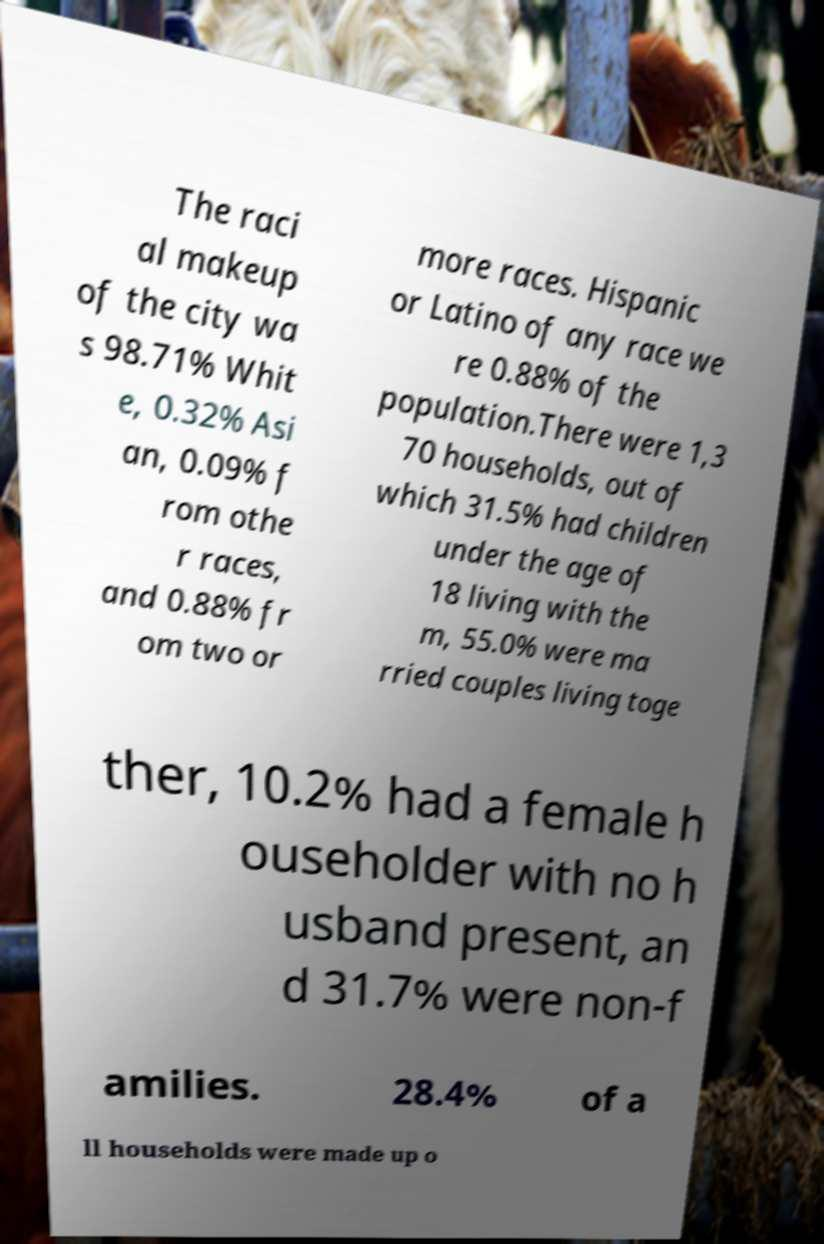Can you read and provide the text displayed in the image?This photo seems to have some interesting text. Can you extract and type it out for me? The raci al makeup of the city wa s 98.71% Whit e, 0.32% Asi an, 0.09% f rom othe r races, and 0.88% fr om two or more races. Hispanic or Latino of any race we re 0.88% of the population.There were 1,3 70 households, out of which 31.5% had children under the age of 18 living with the m, 55.0% were ma rried couples living toge ther, 10.2% had a female h ouseholder with no h usband present, an d 31.7% were non-f amilies. 28.4% of a ll households were made up o 